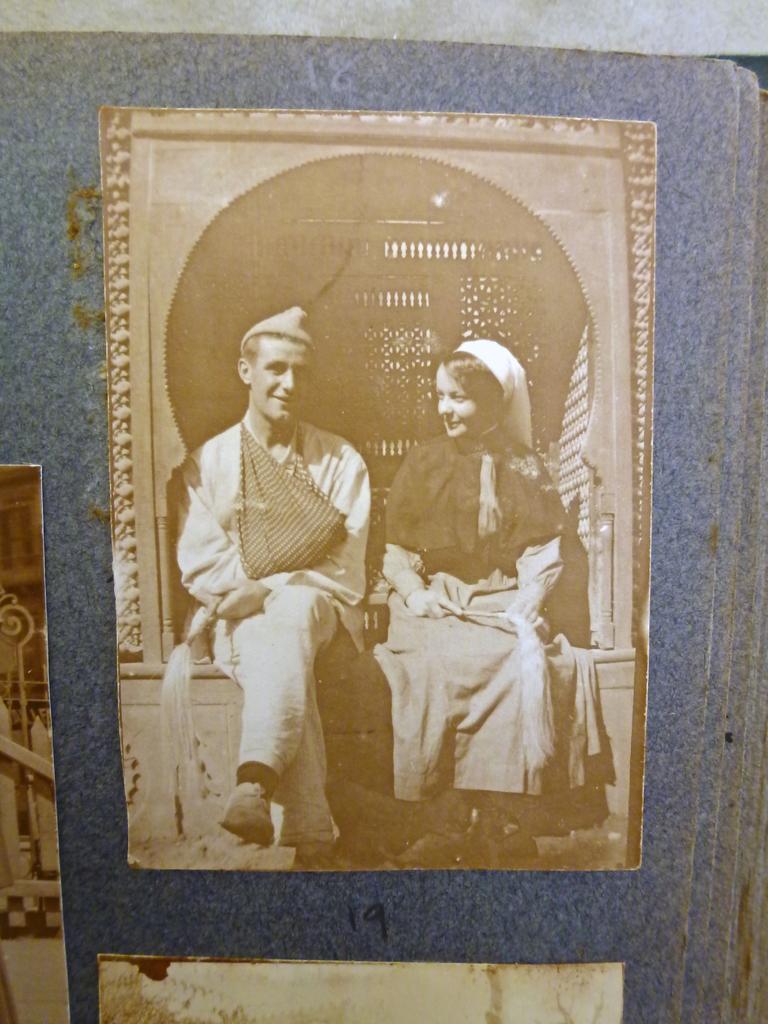Can you describe this image briefly? In this image, we can see photo of a picture contains persons wearing clothes. 